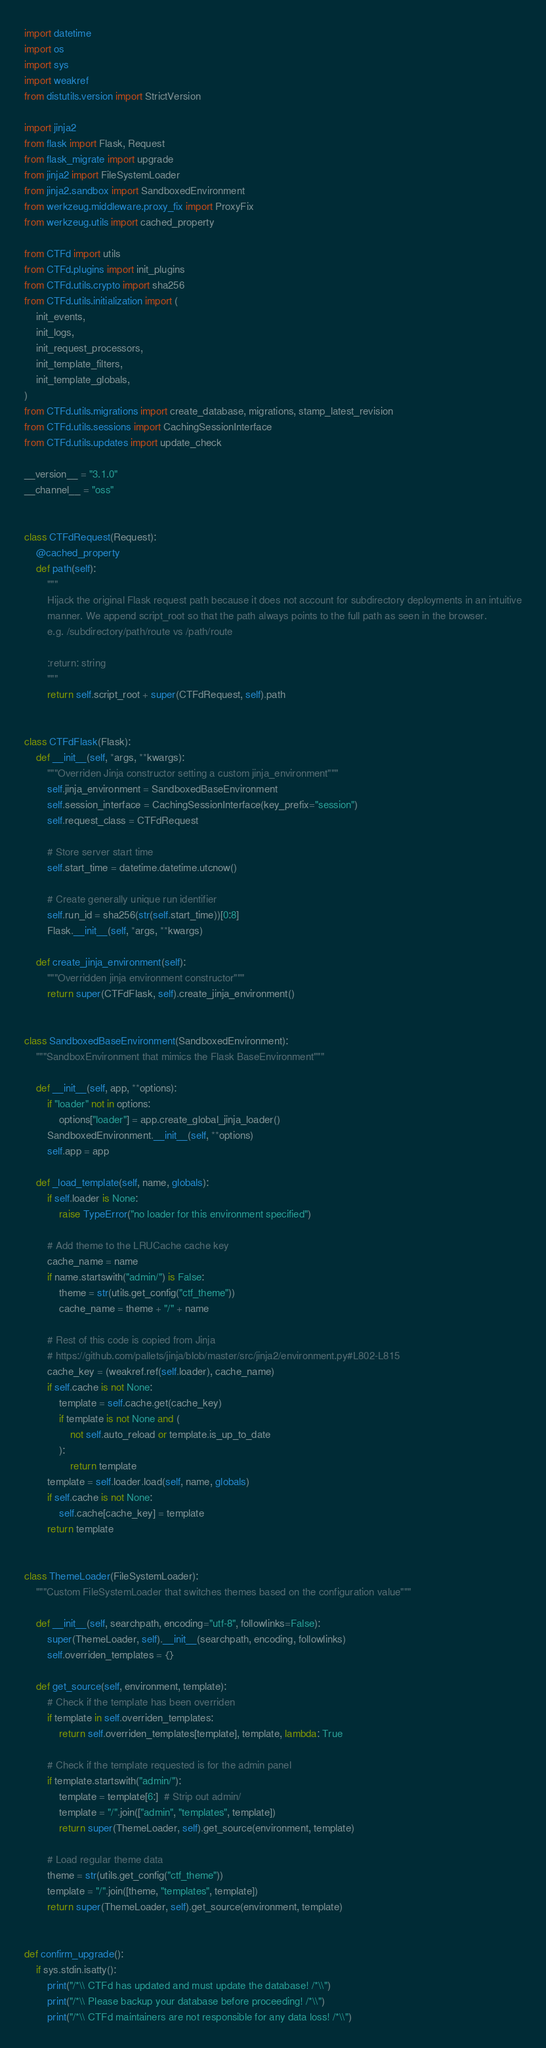Convert code to text. <code><loc_0><loc_0><loc_500><loc_500><_Python_>import datetime
import os
import sys
import weakref
from distutils.version import StrictVersion

import jinja2
from flask import Flask, Request
from flask_migrate import upgrade
from jinja2 import FileSystemLoader
from jinja2.sandbox import SandboxedEnvironment
from werkzeug.middleware.proxy_fix import ProxyFix
from werkzeug.utils import cached_property

from CTFd import utils
from CTFd.plugins import init_plugins
from CTFd.utils.crypto import sha256
from CTFd.utils.initialization import (
    init_events,
    init_logs,
    init_request_processors,
    init_template_filters,
    init_template_globals,
)
from CTFd.utils.migrations import create_database, migrations, stamp_latest_revision
from CTFd.utils.sessions import CachingSessionInterface
from CTFd.utils.updates import update_check

__version__ = "3.1.0"
__channel__ = "oss"


class CTFdRequest(Request):
    @cached_property
    def path(self):
        """
        Hijack the original Flask request path because it does not account for subdirectory deployments in an intuitive
        manner. We append script_root so that the path always points to the full path as seen in the browser.
        e.g. /subdirectory/path/route vs /path/route

        :return: string
        """
        return self.script_root + super(CTFdRequest, self).path


class CTFdFlask(Flask):
    def __init__(self, *args, **kwargs):
        """Overriden Jinja constructor setting a custom jinja_environment"""
        self.jinja_environment = SandboxedBaseEnvironment
        self.session_interface = CachingSessionInterface(key_prefix="session")
        self.request_class = CTFdRequest

        # Store server start time
        self.start_time = datetime.datetime.utcnow()

        # Create generally unique run identifier
        self.run_id = sha256(str(self.start_time))[0:8]
        Flask.__init__(self, *args, **kwargs)

    def create_jinja_environment(self):
        """Overridden jinja environment constructor"""
        return super(CTFdFlask, self).create_jinja_environment()


class SandboxedBaseEnvironment(SandboxedEnvironment):
    """SandboxEnvironment that mimics the Flask BaseEnvironment"""

    def __init__(self, app, **options):
        if "loader" not in options:
            options["loader"] = app.create_global_jinja_loader()
        SandboxedEnvironment.__init__(self, **options)
        self.app = app

    def _load_template(self, name, globals):
        if self.loader is None:
            raise TypeError("no loader for this environment specified")

        # Add theme to the LRUCache cache key
        cache_name = name
        if name.startswith("admin/") is False:
            theme = str(utils.get_config("ctf_theme"))
            cache_name = theme + "/" + name

        # Rest of this code is copied from Jinja
        # https://github.com/pallets/jinja/blob/master/src/jinja2/environment.py#L802-L815
        cache_key = (weakref.ref(self.loader), cache_name)
        if self.cache is not None:
            template = self.cache.get(cache_key)
            if template is not None and (
                not self.auto_reload or template.is_up_to_date
            ):
                return template
        template = self.loader.load(self, name, globals)
        if self.cache is not None:
            self.cache[cache_key] = template
        return template


class ThemeLoader(FileSystemLoader):
    """Custom FileSystemLoader that switches themes based on the configuration value"""

    def __init__(self, searchpath, encoding="utf-8", followlinks=False):
        super(ThemeLoader, self).__init__(searchpath, encoding, followlinks)
        self.overriden_templates = {}

    def get_source(self, environment, template):
        # Check if the template has been overriden
        if template in self.overriden_templates:
            return self.overriden_templates[template], template, lambda: True

        # Check if the template requested is for the admin panel
        if template.startswith("admin/"):
            template = template[6:]  # Strip out admin/
            template = "/".join(["admin", "templates", template])
            return super(ThemeLoader, self).get_source(environment, template)

        # Load regular theme data
        theme = str(utils.get_config("ctf_theme"))
        template = "/".join([theme, "templates", template])
        return super(ThemeLoader, self).get_source(environment, template)


def confirm_upgrade():
    if sys.stdin.isatty():
        print("/*\\ CTFd has updated and must update the database! /*\\")
        print("/*\\ Please backup your database before proceeding! /*\\")
        print("/*\\ CTFd maintainers are not responsible for any data loss! /*\\")</code> 